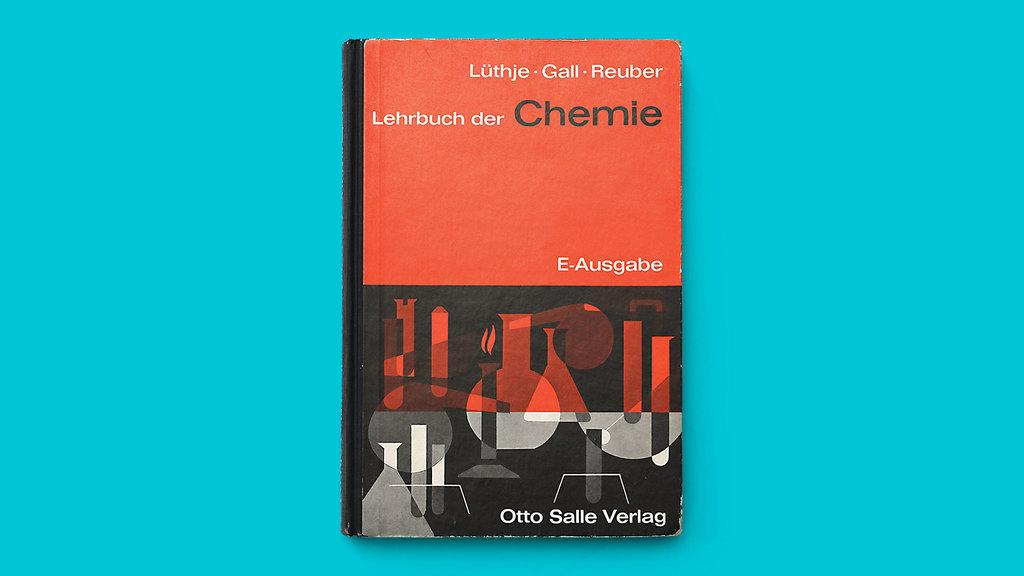<image>
Present a compact description of the photo's key features. A business card for a man named Otto Salle Verlag. 